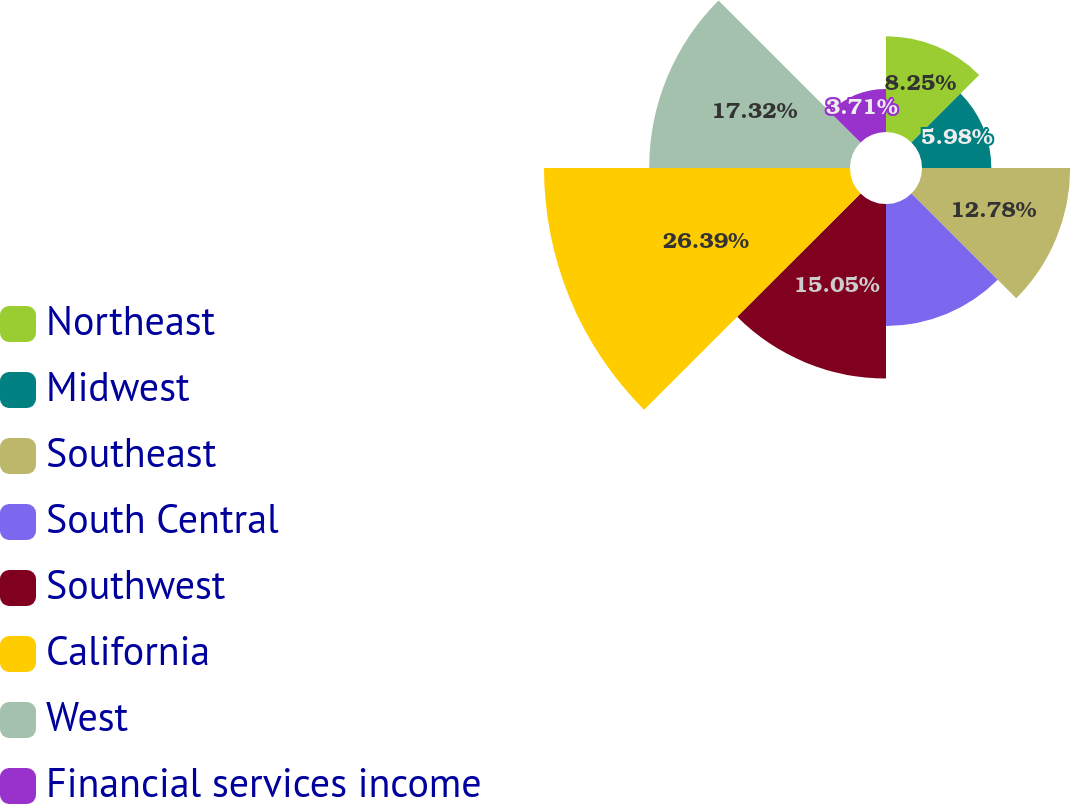<chart> <loc_0><loc_0><loc_500><loc_500><pie_chart><fcel>Northeast<fcel>Midwest<fcel>Southeast<fcel>South Central<fcel>Southwest<fcel>California<fcel>West<fcel>Financial services income<nl><fcel>8.25%<fcel>5.98%<fcel>12.78%<fcel>10.52%<fcel>15.05%<fcel>26.39%<fcel>17.32%<fcel>3.71%<nl></chart> 